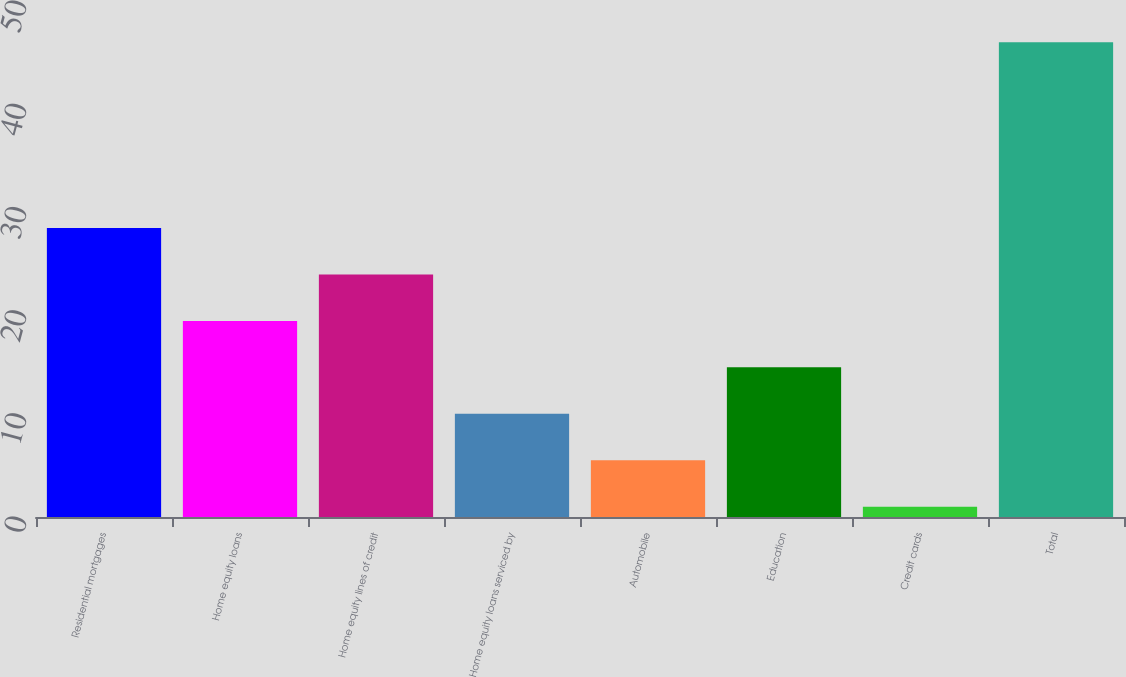Convert chart to OTSL. <chart><loc_0><loc_0><loc_500><loc_500><bar_chart><fcel>Residential mortgages<fcel>Home equity loans<fcel>Home equity lines of credit<fcel>Home equity loans serviced by<fcel>Automobile<fcel>Education<fcel>Credit cards<fcel>Total<nl><fcel>28<fcel>19<fcel>23.5<fcel>10<fcel>5.5<fcel>14.5<fcel>1<fcel>46<nl></chart> 